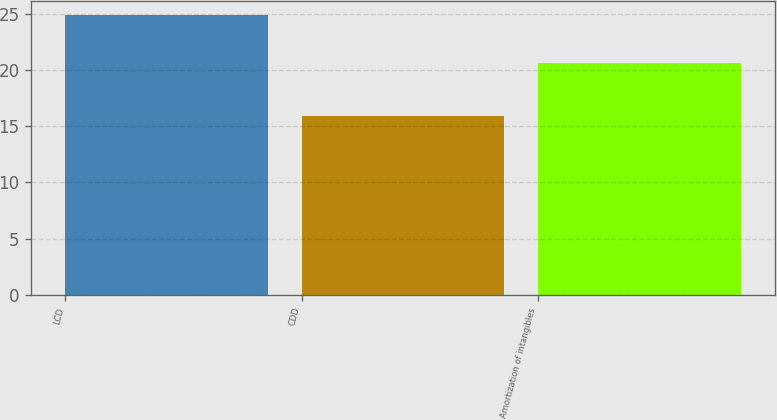Convert chart to OTSL. <chart><loc_0><loc_0><loc_500><loc_500><bar_chart><fcel>LCD<fcel>CDD<fcel>Amortization of intangibles<nl><fcel>24.9<fcel>15.9<fcel>20.6<nl></chart> 